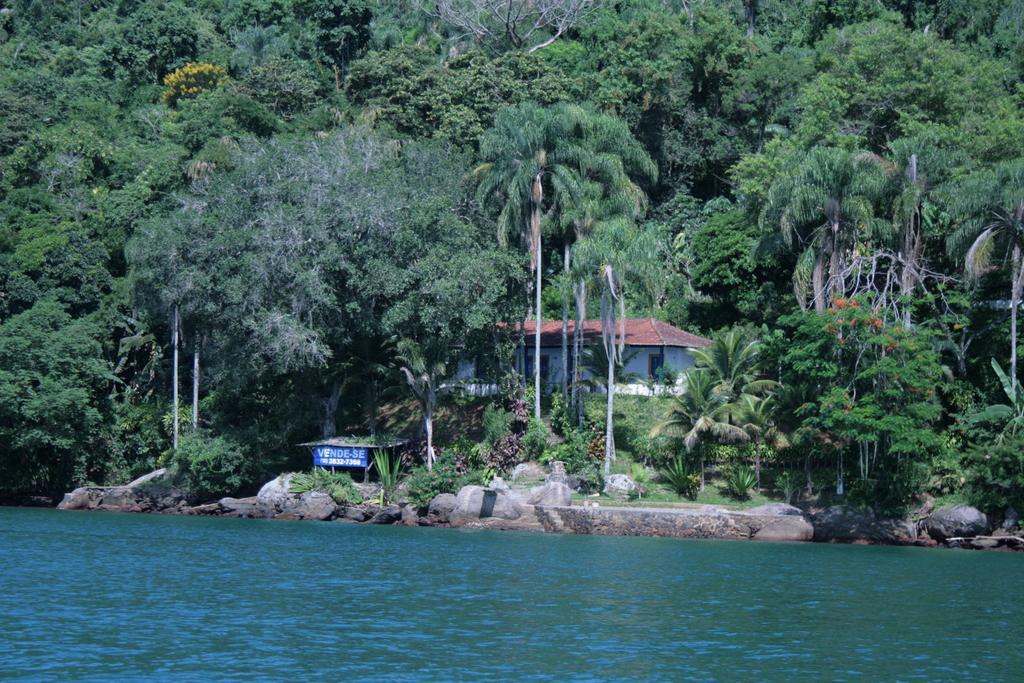Could you give a brief overview of what you see in this image? In this picture we can see the water, stones, banner, house and trees. 